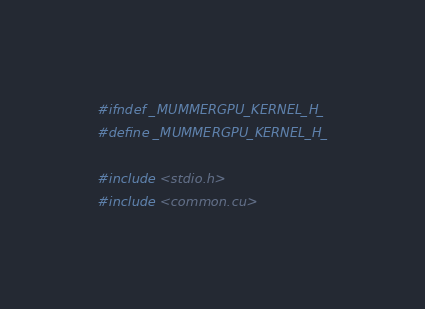Convert code to text. <code><loc_0><loc_0><loc_500><loc_500><_Cuda_>#ifndef _MUMMERGPU_KERNEL_H_
#define _MUMMERGPU_KERNEL_H_

#include <stdio.h>
#include <common.cu>
</code> 